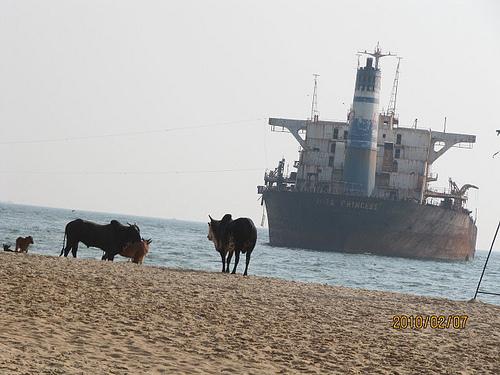Why is the animal on the beach?
Be succinct. Wandering. What animal is in this sense?
Keep it brief. Cow. Is there a plane there?
Quick response, please. No. How many animals are shown?
Answer briefly. 4. 